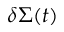<formula> <loc_0><loc_0><loc_500><loc_500>\delta \Sigma ( t )</formula> 